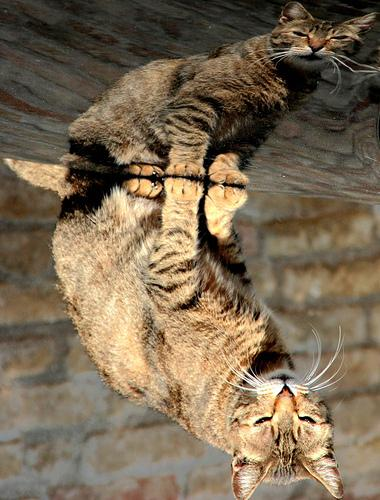Question: what is the animal in the picture?
Choices:
A. Cow.
B. Dog.
C. Cat.
D. Bird.
Answer with the letter. Answer: C Question: when is this taken?
Choices:
A. In the evening.
B. In the morning.
C. During the day.
D. At night.
Answer with the letter. Answer: C Question: who is in this photo?
Choices:
A. A feline.
B. A dog.
C. An equine.
D. A cow.
Answer with the letter. Answer: A Question: what is the cat doing?
Choices:
A. Eathing.
B. Rolling a ball.
C. Sitting.
D. Chasing a mouse.
Answer with the letter. Answer: C 